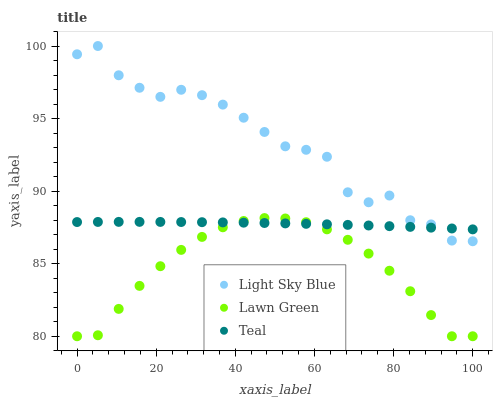Does Lawn Green have the minimum area under the curve?
Answer yes or no. Yes. Does Light Sky Blue have the maximum area under the curve?
Answer yes or no. Yes. Does Teal have the minimum area under the curve?
Answer yes or no. No. Does Teal have the maximum area under the curve?
Answer yes or no. No. Is Teal the smoothest?
Answer yes or no. Yes. Is Light Sky Blue the roughest?
Answer yes or no. Yes. Is Light Sky Blue the smoothest?
Answer yes or no. No. Is Teal the roughest?
Answer yes or no. No. Does Lawn Green have the lowest value?
Answer yes or no. Yes. Does Light Sky Blue have the lowest value?
Answer yes or no. No. Does Light Sky Blue have the highest value?
Answer yes or no. Yes. Does Teal have the highest value?
Answer yes or no. No. Is Lawn Green less than Light Sky Blue?
Answer yes or no. Yes. Is Light Sky Blue greater than Lawn Green?
Answer yes or no. Yes. Does Lawn Green intersect Teal?
Answer yes or no. Yes. Is Lawn Green less than Teal?
Answer yes or no. No. Is Lawn Green greater than Teal?
Answer yes or no. No. Does Lawn Green intersect Light Sky Blue?
Answer yes or no. No. 